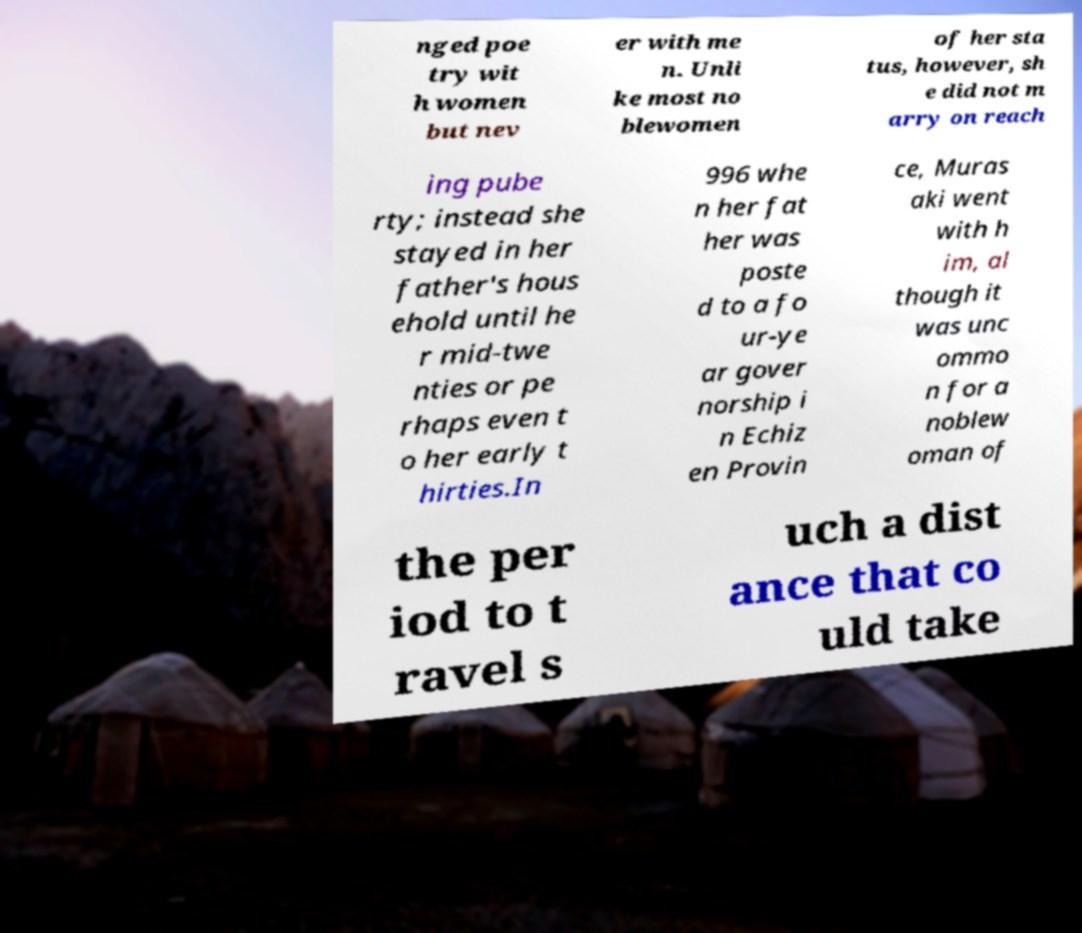For documentation purposes, I need the text within this image transcribed. Could you provide that? nged poe try wit h women but nev er with me n. Unli ke most no blewomen of her sta tus, however, sh e did not m arry on reach ing pube rty; instead she stayed in her father's hous ehold until he r mid-twe nties or pe rhaps even t o her early t hirties.In 996 whe n her fat her was poste d to a fo ur-ye ar gover norship i n Echiz en Provin ce, Muras aki went with h im, al though it was unc ommo n for a noblew oman of the per iod to t ravel s uch a dist ance that co uld take 